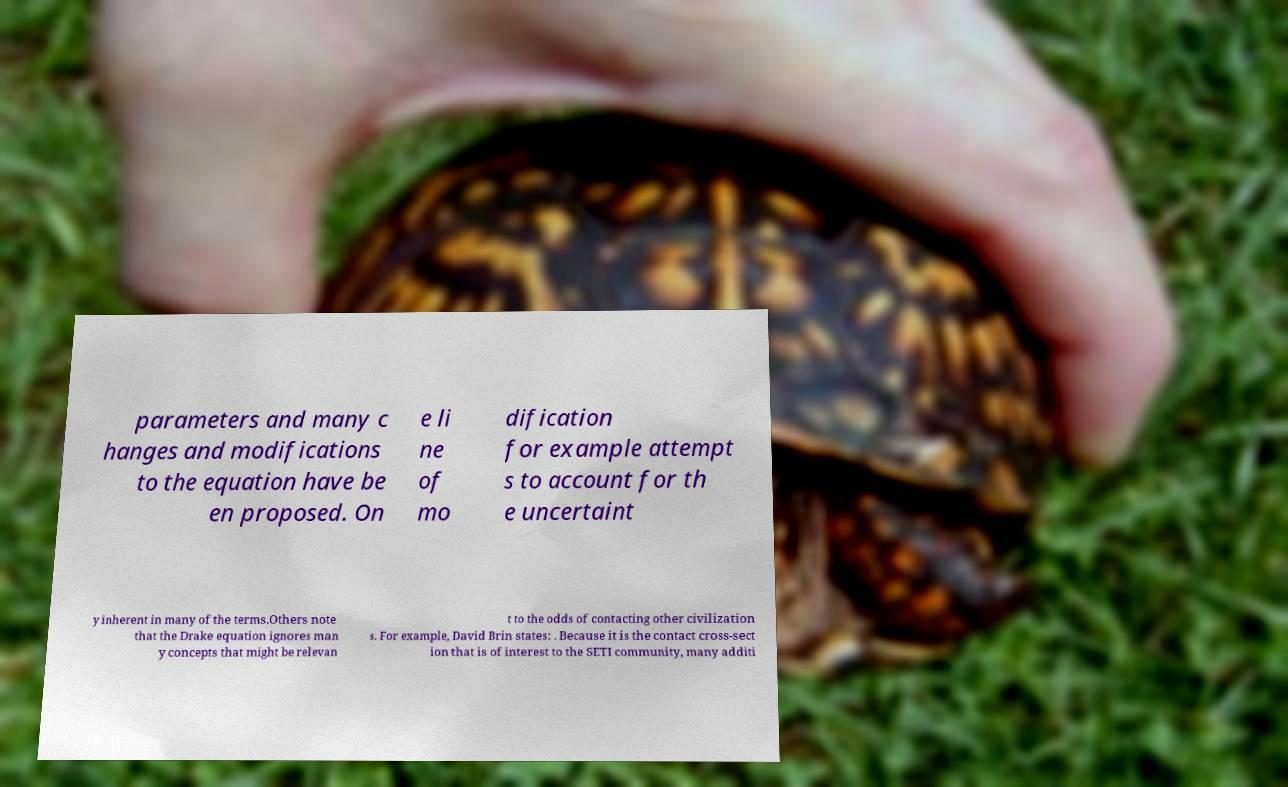Please identify and transcribe the text found in this image. parameters and many c hanges and modifications to the equation have be en proposed. On e li ne of mo dification for example attempt s to account for th e uncertaint y inherent in many of the terms.Others note that the Drake equation ignores man y concepts that might be relevan t to the odds of contacting other civilization s. For example, David Brin states: . Because it is the contact cross-sect ion that is of interest to the SETI community, many additi 